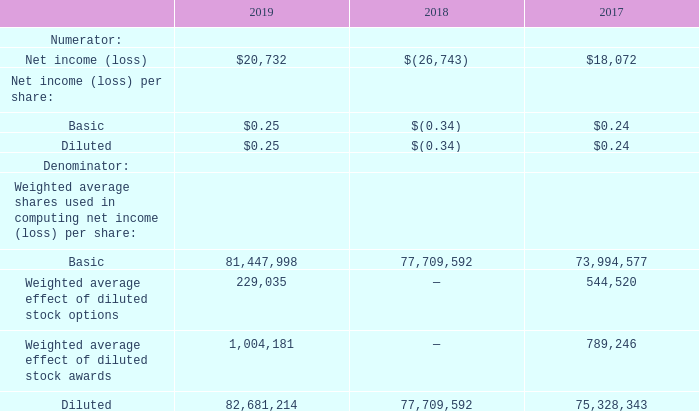5. Net Income (Loss) per Share
The Company calculates basic earnings per share by dividing the net income (loss) by the weighted average number of shares of common stock outstanding for the period. The diluted earnings per share is computed by giving effect to all potential dilutive common stock equivalents outstanding for the period using the treasury stock method. For purposes of this calculation, options to purchase common stock, stock awards, and the Convertible Senior Notes are considered to be common stock equivalents.
Since the Company has the intent and ability to settle the principal amount of the Convertible Senior Notes in cash and any excess in shares of the Company’s common stock, the Company uses the treasury stock method for calculating any potential dilutive effect of the conversion spread on diluted net income per share, if applicable.
The conversion spread will have a dilutive impact on net income (loss) per share of common stock when the average market price of the Company’s common stock for a given period exceeds the conversion price of $113.75 per share for the Convertible Senior Notes. During the fiscal years ended July 31, 2019 and 2018, the Company’s weighted average common stock price was below the conversion price of the Convertible Senior Notes.
The following table sets forth the computation of the Company’s basic and diluted net income per share for the years endedJ uly 31, 2019, 2018 and 2017 (in thousands, except share and per share amounts):
How is the basic earnings per share calculated? By dividing the net income (loss) by the weighted average number of shares of common stock outstanding for the period. What was the Net income (loss) in 2019, 2018 and 2017 respectively?
Answer scale should be: thousand. $20,732, $(26,743), $18,072. What was the basic Net income (loss) per share in 2019? $0.25. In which year was basic Net income (loss) per share negative? Locate and analyze basic in row 5
answer: 2018. What was the change in the basic Weighted average shares used in computing net income (loss) per share from 2018 to 2019? 81,447,998 - 77,709,592
Answer: 3738406. What was the average Diluted Weighted average shares used in computing net income (loss) per share for 2018 and 2019? (82,681,214 + 77,709,592 + 75,328,343) / 3
Answer: 78573049.67. 